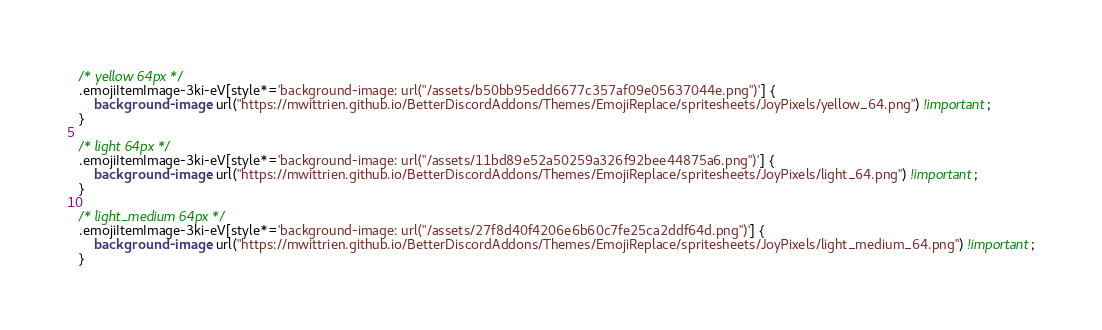<code> <loc_0><loc_0><loc_500><loc_500><_CSS_>/* yellow 64px */
.emojiItemImage-3ki-eV[style*='background-image: url("/assets/b50bb95edd6677c357af09e05637044e.png")'] {
	background-image: url("https://mwittrien.github.io/BetterDiscordAddons/Themes/EmojiReplace/spritesheets/JoyPixels/yellow_64.png") !important;
}

/* light 64px */
.emojiItemImage-3ki-eV[style*='background-image: url("/assets/11bd89e52a50259a326f92bee44875a6.png")'] {
	background-image: url("https://mwittrien.github.io/BetterDiscordAddons/Themes/EmojiReplace/spritesheets/JoyPixels/light_64.png") !important;
}

/* light_medium 64px */
.emojiItemImage-3ki-eV[style*='background-image: url("/assets/27f8d40f4206e6b60c7fe25ca2ddf64d.png")'] {
	background-image: url("https://mwittrien.github.io/BetterDiscordAddons/Themes/EmojiReplace/spritesheets/JoyPixels/light_medium_64.png") !important;
}
</code> 